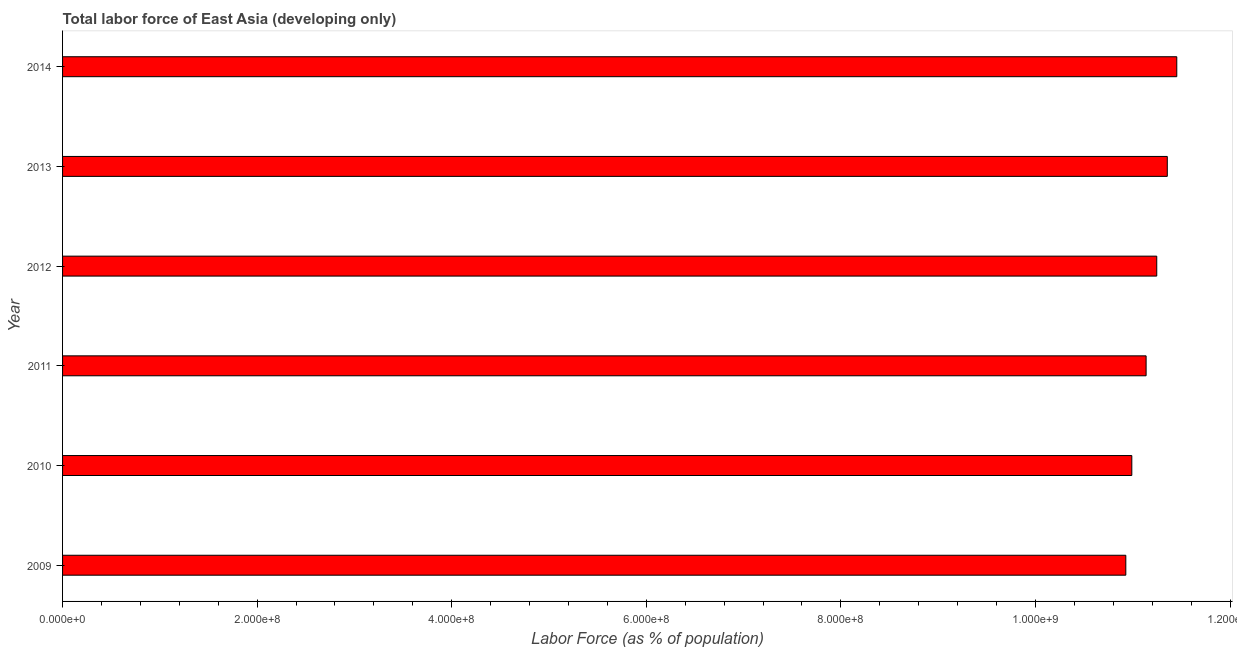Does the graph contain any zero values?
Offer a terse response. No. What is the title of the graph?
Ensure brevity in your answer.  Total labor force of East Asia (developing only). What is the label or title of the X-axis?
Provide a succinct answer. Labor Force (as % of population). What is the label or title of the Y-axis?
Your response must be concise. Year. What is the total labor force in 2012?
Your answer should be compact. 1.12e+09. Across all years, what is the maximum total labor force?
Offer a very short reply. 1.15e+09. Across all years, what is the minimum total labor force?
Provide a succinct answer. 1.09e+09. In which year was the total labor force maximum?
Your response must be concise. 2014. What is the sum of the total labor force?
Offer a terse response. 6.71e+09. What is the difference between the total labor force in 2012 and 2014?
Your response must be concise. -2.06e+07. What is the average total labor force per year?
Offer a very short reply. 1.12e+09. What is the median total labor force?
Give a very brief answer. 1.12e+09. Do a majority of the years between 2014 and 2013 (inclusive) have total labor force greater than 840000000 %?
Your answer should be compact. No. Is the total labor force in 2010 less than that in 2013?
Provide a short and direct response. Yes. What is the difference between the highest and the second highest total labor force?
Make the answer very short. 9.75e+06. What is the difference between the highest and the lowest total labor force?
Your answer should be very brief. 5.24e+07. In how many years, is the total labor force greater than the average total labor force taken over all years?
Keep it short and to the point. 3. How many bars are there?
Your answer should be very brief. 6. What is the difference between two consecutive major ticks on the X-axis?
Offer a terse response. 2.00e+08. What is the Labor Force (as % of population) of 2009?
Your answer should be compact. 1.09e+09. What is the Labor Force (as % of population) in 2010?
Offer a terse response. 1.10e+09. What is the Labor Force (as % of population) of 2011?
Your response must be concise. 1.11e+09. What is the Labor Force (as % of population) of 2012?
Your answer should be compact. 1.12e+09. What is the Labor Force (as % of population) of 2013?
Give a very brief answer. 1.14e+09. What is the Labor Force (as % of population) in 2014?
Your answer should be very brief. 1.15e+09. What is the difference between the Labor Force (as % of population) in 2009 and 2010?
Your answer should be very brief. -6.16e+06. What is the difference between the Labor Force (as % of population) in 2009 and 2011?
Provide a short and direct response. -2.09e+07. What is the difference between the Labor Force (as % of population) in 2009 and 2012?
Keep it short and to the point. -3.18e+07. What is the difference between the Labor Force (as % of population) in 2009 and 2013?
Your answer should be compact. -4.26e+07. What is the difference between the Labor Force (as % of population) in 2009 and 2014?
Your answer should be very brief. -5.24e+07. What is the difference between the Labor Force (as % of population) in 2010 and 2011?
Give a very brief answer. -1.47e+07. What is the difference between the Labor Force (as % of population) in 2010 and 2012?
Your answer should be compact. -2.56e+07. What is the difference between the Labor Force (as % of population) in 2010 and 2013?
Offer a terse response. -3.65e+07. What is the difference between the Labor Force (as % of population) in 2010 and 2014?
Make the answer very short. -4.62e+07. What is the difference between the Labor Force (as % of population) in 2011 and 2012?
Ensure brevity in your answer.  -1.09e+07. What is the difference between the Labor Force (as % of population) in 2011 and 2013?
Make the answer very short. -2.18e+07. What is the difference between the Labor Force (as % of population) in 2011 and 2014?
Offer a very short reply. -3.15e+07. What is the difference between the Labor Force (as % of population) in 2012 and 2013?
Offer a terse response. -1.08e+07. What is the difference between the Labor Force (as % of population) in 2012 and 2014?
Make the answer very short. -2.06e+07. What is the difference between the Labor Force (as % of population) in 2013 and 2014?
Keep it short and to the point. -9.75e+06. What is the ratio of the Labor Force (as % of population) in 2009 to that in 2010?
Provide a short and direct response. 0.99. What is the ratio of the Labor Force (as % of population) in 2009 to that in 2013?
Your answer should be compact. 0.96. What is the ratio of the Labor Force (as % of population) in 2009 to that in 2014?
Ensure brevity in your answer.  0.95. What is the ratio of the Labor Force (as % of population) in 2010 to that in 2012?
Make the answer very short. 0.98. What is the ratio of the Labor Force (as % of population) in 2010 to that in 2013?
Offer a very short reply. 0.97. What is the ratio of the Labor Force (as % of population) in 2011 to that in 2013?
Give a very brief answer. 0.98. What is the ratio of the Labor Force (as % of population) in 2011 to that in 2014?
Offer a very short reply. 0.97. What is the ratio of the Labor Force (as % of population) in 2013 to that in 2014?
Offer a very short reply. 0.99. 